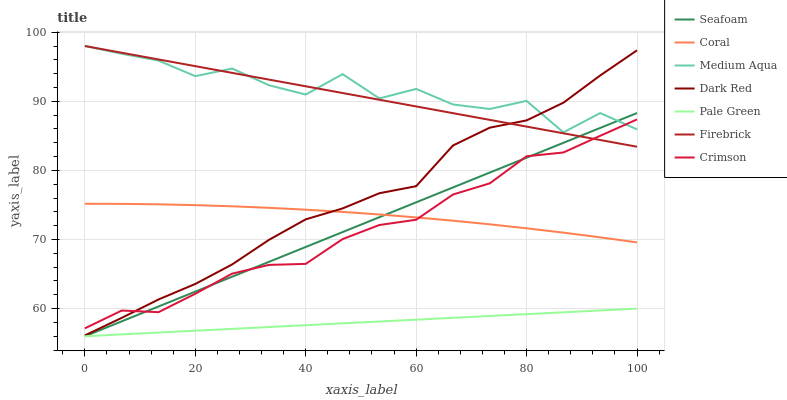Does Pale Green have the minimum area under the curve?
Answer yes or no. Yes. Does Medium Aqua have the maximum area under the curve?
Answer yes or no. Yes. Does Firebrick have the minimum area under the curve?
Answer yes or no. No. Does Firebrick have the maximum area under the curve?
Answer yes or no. No. Is Pale Green the smoothest?
Answer yes or no. Yes. Is Medium Aqua the roughest?
Answer yes or no. Yes. Is Firebrick the smoothest?
Answer yes or no. No. Is Firebrick the roughest?
Answer yes or no. No. Does Seafoam have the lowest value?
Answer yes or no. Yes. Does Firebrick have the lowest value?
Answer yes or no. No. Does Medium Aqua have the highest value?
Answer yes or no. Yes. Does Seafoam have the highest value?
Answer yes or no. No. Is Pale Green less than Firebrick?
Answer yes or no. Yes. Is Firebrick greater than Pale Green?
Answer yes or no. Yes. Does Medium Aqua intersect Crimson?
Answer yes or no. Yes. Is Medium Aqua less than Crimson?
Answer yes or no. No. Is Medium Aqua greater than Crimson?
Answer yes or no. No. Does Pale Green intersect Firebrick?
Answer yes or no. No. 